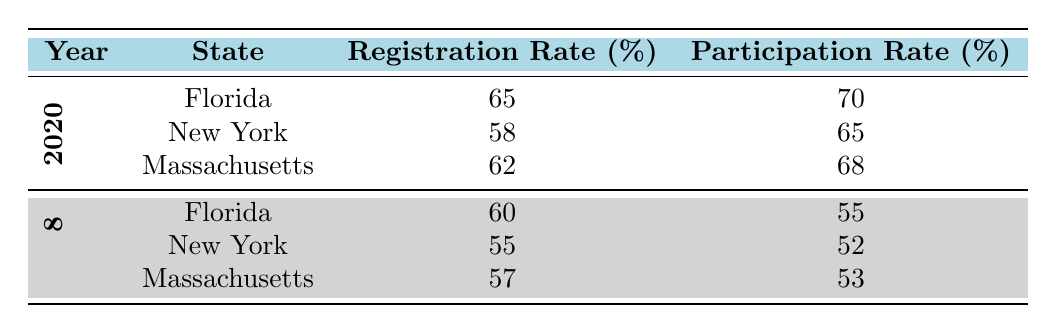What was the voter registration rate in Florida for the year 2020? The table shows that for the year 2020 in Florida, the voter registration rate is listed specifically as 65%.
Answer: 65% What was the voter participation rate in Massachusetts in 2018? According to the table, the voter participation rate in Massachusetts for the year 2018 is 53%.
Answer: 53% Is the voter registration rate in New York higher in 2020 than in 2018? The table indicates that the registration rate in New York is 58% for 2020 and 55% for 2018. Since 58% is greater than 55%, the statement is true.
Answer: Yes What is the average voter participation rate for the years 2018 across all states? To calculate the average for 2018, we list the participation rates: Florida 55%, New York 52%, and Massachusetts 53%. Sum these rates: 55 + 52 + 53 = 160. There are 3 states, so the average is 160 / 3 = 53.33%.
Answer: 53.33% In which state did the voter participation rate improve the most between 2018 and 2020? To find the state with the greatest improvement, we calculate the changes: Florida (55% to 70%) = 15%, New York (52% to 65%) = 13%, and Massachusetts (53% to 68%) = 15%. The improvements in Florida and Massachusetts both equal 15%, so they have the highest improvement.
Answer: Florida and Massachusetts What was the lowest voter participation rate recorded in the table? Reviewing the table, the lowest participation rate is found in New York for 2018, which is 52%.
Answer: 52% Did the voter registration rate decrease in Massachusetts from 2018 to 2020? The table shows that in Massachusetts, the voter registration rate is 57% in 2018 and 62% in 2020. Since 62% is higher than 57%, the statement is false.
Answer: No What is the total voter registration rate for Florida across the two years provided? To find the total voter registration rate for Florida, add the rates: 60% (2018) + 65% (2020) = 125%.
Answer: 125% Which state had both the highest voter registration and participation rates in 2020? In 2020, Florida had a registration rate of 65% and a participation rate of 70%, which are both the highest when compared with New York and Massachusetts.
Answer: Florida 